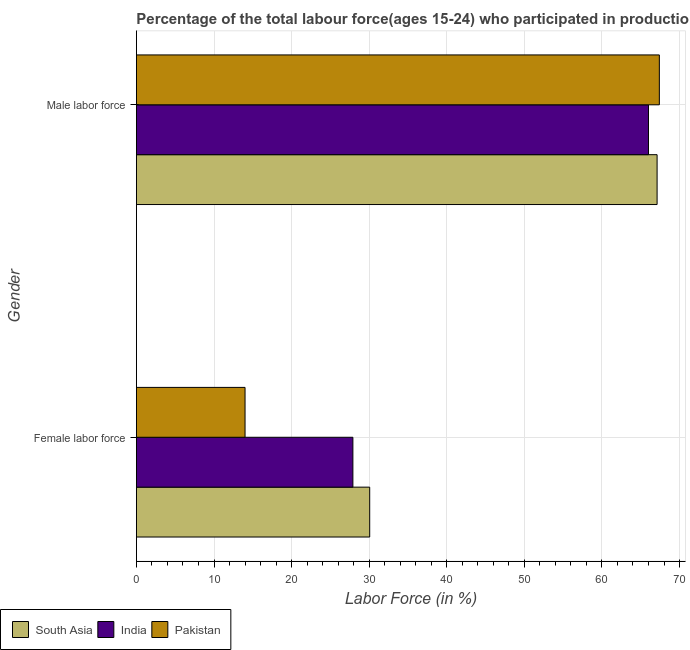How many different coloured bars are there?
Your response must be concise. 3. How many groups of bars are there?
Provide a succinct answer. 2. Are the number of bars per tick equal to the number of legend labels?
Offer a very short reply. Yes. What is the label of the 1st group of bars from the top?
Your answer should be very brief. Male labor force. What is the percentage of male labour force in Pakistan?
Provide a succinct answer. 67.4. Across all countries, what is the maximum percentage of male labour force?
Your answer should be very brief. 67.4. In which country was the percentage of male labour force minimum?
Your response must be concise. India. What is the total percentage of female labor force in the graph?
Give a very brief answer. 71.97. What is the difference between the percentage of female labor force in Pakistan and that in South Asia?
Offer a terse response. -16.07. What is the difference between the percentage of female labor force in Pakistan and the percentage of male labour force in South Asia?
Keep it short and to the point. -53.11. What is the average percentage of female labor force per country?
Offer a very short reply. 23.99. What is the difference between the percentage of female labor force and percentage of male labour force in India?
Provide a short and direct response. -38.1. What is the ratio of the percentage of female labor force in India to that in South Asia?
Make the answer very short. 0.93. What does the 3rd bar from the bottom in Female labor force represents?
Give a very brief answer. Pakistan. How many bars are there?
Your answer should be very brief. 6. What is the difference between two consecutive major ticks on the X-axis?
Your response must be concise. 10. Are the values on the major ticks of X-axis written in scientific E-notation?
Make the answer very short. No. Does the graph contain any zero values?
Offer a very short reply. No. Does the graph contain grids?
Your answer should be very brief. Yes. Where does the legend appear in the graph?
Offer a terse response. Bottom left. How many legend labels are there?
Provide a succinct answer. 3. What is the title of the graph?
Offer a terse response. Percentage of the total labour force(ages 15-24) who participated in production in 1997. Does "Bolivia" appear as one of the legend labels in the graph?
Make the answer very short. No. What is the label or title of the X-axis?
Provide a succinct answer. Labor Force (in %). What is the Labor Force (in %) of South Asia in Female labor force?
Your response must be concise. 30.07. What is the Labor Force (in %) of India in Female labor force?
Your response must be concise. 27.9. What is the Labor Force (in %) of South Asia in Male labor force?
Your response must be concise. 67.11. What is the Labor Force (in %) in India in Male labor force?
Provide a short and direct response. 66. What is the Labor Force (in %) of Pakistan in Male labor force?
Your answer should be very brief. 67.4. Across all Gender, what is the maximum Labor Force (in %) of South Asia?
Give a very brief answer. 67.11. Across all Gender, what is the maximum Labor Force (in %) of India?
Your answer should be compact. 66. Across all Gender, what is the maximum Labor Force (in %) in Pakistan?
Provide a short and direct response. 67.4. Across all Gender, what is the minimum Labor Force (in %) in South Asia?
Provide a succinct answer. 30.07. Across all Gender, what is the minimum Labor Force (in %) of India?
Provide a succinct answer. 27.9. Across all Gender, what is the minimum Labor Force (in %) in Pakistan?
Provide a short and direct response. 14. What is the total Labor Force (in %) of South Asia in the graph?
Offer a very short reply. 97.18. What is the total Labor Force (in %) in India in the graph?
Ensure brevity in your answer.  93.9. What is the total Labor Force (in %) in Pakistan in the graph?
Give a very brief answer. 81.4. What is the difference between the Labor Force (in %) in South Asia in Female labor force and that in Male labor force?
Your answer should be compact. -37.04. What is the difference between the Labor Force (in %) of India in Female labor force and that in Male labor force?
Provide a succinct answer. -38.1. What is the difference between the Labor Force (in %) of Pakistan in Female labor force and that in Male labor force?
Provide a succinct answer. -53.4. What is the difference between the Labor Force (in %) in South Asia in Female labor force and the Labor Force (in %) in India in Male labor force?
Give a very brief answer. -35.93. What is the difference between the Labor Force (in %) in South Asia in Female labor force and the Labor Force (in %) in Pakistan in Male labor force?
Give a very brief answer. -37.33. What is the difference between the Labor Force (in %) of India in Female labor force and the Labor Force (in %) of Pakistan in Male labor force?
Offer a very short reply. -39.5. What is the average Labor Force (in %) of South Asia per Gender?
Provide a succinct answer. 48.59. What is the average Labor Force (in %) of India per Gender?
Your answer should be very brief. 46.95. What is the average Labor Force (in %) in Pakistan per Gender?
Provide a succinct answer. 40.7. What is the difference between the Labor Force (in %) of South Asia and Labor Force (in %) of India in Female labor force?
Make the answer very short. 2.17. What is the difference between the Labor Force (in %) in South Asia and Labor Force (in %) in Pakistan in Female labor force?
Your answer should be very brief. 16.07. What is the difference between the Labor Force (in %) in India and Labor Force (in %) in Pakistan in Female labor force?
Your answer should be compact. 13.9. What is the difference between the Labor Force (in %) of South Asia and Labor Force (in %) of India in Male labor force?
Provide a succinct answer. 1.11. What is the difference between the Labor Force (in %) of South Asia and Labor Force (in %) of Pakistan in Male labor force?
Give a very brief answer. -0.29. What is the difference between the Labor Force (in %) in India and Labor Force (in %) in Pakistan in Male labor force?
Your response must be concise. -1.4. What is the ratio of the Labor Force (in %) of South Asia in Female labor force to that in Male labor force?
Your answer should be compact. 0.45. What is the ratio of the Labor Force (in %) of India in Female labor force to that in Male labor force?
Offer a terse response. 0.42. What is the ratio of the Labor Force (in %) of Pakistan in Female labor force to that in Male labor force?
Provide a succinct answer. 0.21. What is the difference between the highest and the second highest Labor Force (in %) in South Asia?
Provide a succinct answer. 37.04. What is the difference between the highest and the second highest Labor Force (in %) in India?
Ensure brevity in your answer.  38.1. What is the difference between the highest and the second highest Labor Force (in %) of Pakistan?
Make the answer very short. 53.4. What is the difference between the highest and the lowest Labor Force (in %) in South Asia?
Keep it short and to the point. 37.04. What is the difference between the highest and the lowest Labor Force (in %) of India?
Offer a very short reply. 38.1. What is the difference between the highest and the lowest Labor Force (in %) in Pakistan?
Your answer should be compact. 53.4. 